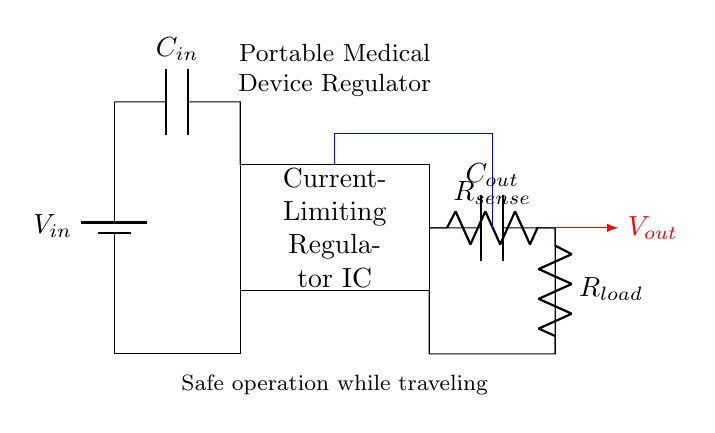What is the type of regulator used in this circuit? The circuit uses a current-limiting regulator, as indicated by the label on the rectangle showing the regulator IC.
Answer: current-limiting regulator What do the components C_in and C_out represent? C_in is the input capacitor, which smooths the input voltage, while C_out is the output capacitor, which stabilizes the output voltage. Both are crucial for regulator performance.
Answer: input and output capacitors What is the role of R_load in this circuit? R_load acts as the load resistor, which represents the device being powered, allowing the circuit to deliver the necessary current to the load.
Answer: load resistor How does feedback connect in this circuit? The feedback is shown by the blue line, which connects from the output side to the regulator IC, allowing the regulator to maintain output voltage by adjusting itself based on the load condition.
Answer: through a feedback loop What does R_sense do within this regulator? R_sense is a current sense resistor that measures the current flowing to the load, enabling the regulator to control the output by limiting the maximum current based on its reading.
Answer: current sense resistor What is the primary purpose of the portable medical device regulator? The main purpose is to ensure safe operation while traveling by controlling the output voltage and current supplied to the medical device, preventing overload conditions.
Answer: safe operation 